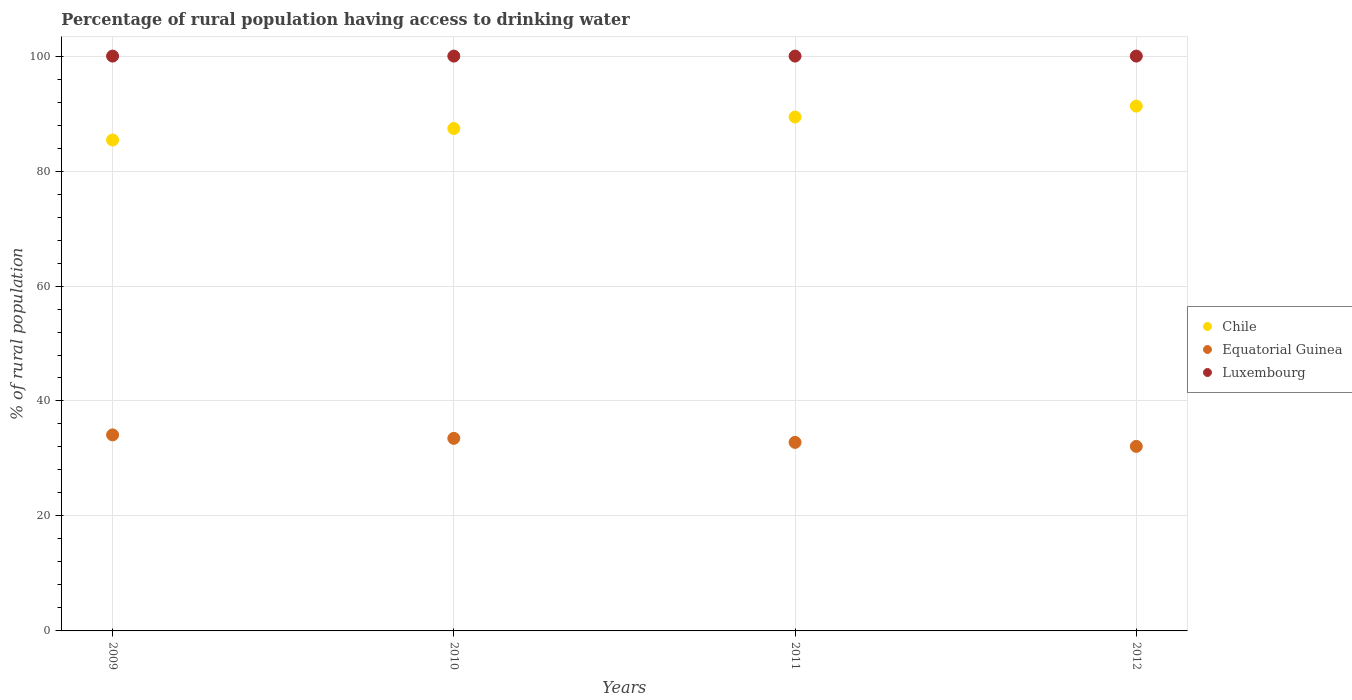Is the number of dotlines equal to the number of legend labels?
Your answer should be compact. Yes. What is the percentage of rural population having access to drinking water in Luxembourg in 2012?
Your response must be concise. 100. Across all years, what is the maximum percentage of rural population having access to drinking water in Luxembourg?
Ensure brevity in your answer.  100. Across all years, what is the minimum percentage of rural population having access to drinking water in Equatorial Guinea?
Provide a short and direct response. 32.1. In which year was the percentage of rural population having access to drinking water in Luxembourg maximum?
Your response must be concise. 2009. What is the total percentage of rural population having access to drinking water in Equatorial Guinea in the graph?
Give a very brief answer. 132.5. What is the difference between the percentage of rural population having access to drinking water in Chile in 2011 and that in 2012?
Ensure brevity in your answer.  -1.9. What is the difference between the percentage of rural population having access to drinking water in Luxembourg in 2009 and the percentage of rural population having access to drinking water in Chile in 2010?
Offer a very short reply. 12.6. What is the average percentage of rural population having access to drinking water in Chile per year?
Provide a short and direct response. 88.38. In the year 2009, what is the difference between the percentage of rural population having access to drinking water in Equatorial Guinea and percentage of rural population having access to drinking water in Chile?
Ensure brevity in your answer.  -51.3. What is the ratio of the percentage of rural population having access to drinking water in Chile in 2009 to that in 2010?
Offer a terse response. 0.98. Is the percentage of rural population having access to drinking water in Equatorial Guinea in 2011 less than that in 2012?
Offer a very short reply. No. What is the difference between the highest and the lowest percentage of rural population having access to drinking water in Chile?
Offer a terse response. 5.9. In how many years, is the percentage of rural population having access to drinking water in Equatorial Guinea greater than the average percentage of rural population having access to drinking water in Equatorial Guinea taken over all years?
Provide a short and direct response. 2. Is the sum of the percentage of rural population having access to drinking water in Luxembourg in 2010 and 2011 greater than the maximum percentage of rural population having access to drinking water in Equatorial Guinea across all years?
Your answer should be very brief. Yes. Is it the case that in every year, the sum of the percentage of rural population having access to drinking water in Luxembourg and percentage of rural population having access to drinking water in Equatorial Guinea  is greater than the percentage of rural population having access to drinking water in Chile?
Make the answer very short. Yes. Does the percentage of rural population having access to drinking water in Luxembourg monotonically increase over the years?
Make the answer very short. No. Is the percentage of rural population having access to drinking water in Luxembourg strictly greater than the percentage of rural population having access to drinking water in Equatorial Guinea over the years?
Your answer should be compact. Yes. Is the percentage of rural population having access to drinking water in Luxembourg strictly less than the percentage of rural population having access to drinking water in Equatorial Guinea over the years?
Offer a very short reply. No. How many dotlines are there?
Offer a very short reply. 3. How many years are there in the graph?
Provide a short and direct response. 4. What is the difference between two consecutive major ticks on the Y-axis?
Your answer should be very brief. 20. Does the graph contain grids?
Your answer should be compact. Yes. How many legend labels are there?
Ensure brevity in your answer.  3. How are the legend labels stacked?
Make the answer very short. Vertical. What is the title of the graph?
Your answer should be very brief. Percentage of rural population having access to drinking water. Does "Grenada" appear as one of the legend labels in the graph?
Provide a short and direct response. No. What is the label or title of the X-axis?
Your response must be concise. Years. What is the label or title of the Y-axis?
Ensure brevity in your answer.  % of rural population. What is the % of rural population of Chile in 2009?
Your answer should be very brief. 85.4. What is the % of rural population in Equatorial Guinea in 2009?
Make the answer very short. 34.1. What is the % of rural population of Luxembourg in 2009?
Your response must be concise. 100. What is the % of rural population of Chile in 2010?
Offer a very short reply. 87.4. What is the % of rural population in Equatorial Guinea in 2010?
Keep it short and to the point. 33.5. What is the % of rural population of Chile in 2011?
Ensure brevity in your answer.  89.4. What is the % of rural population in Equatorial Guinea in 2011?
Your answer should be compact. 32.8. What is the % of rural population of Chile in 2012?
Provide a short and direct response. 91.3. What is the % of rural population of Equatorial Guinea in 2012?
Provide a short and direct response. 32.1. What is the % of rural population in Luxembourg in 2012?
Your answer should be very brief. 100. Across all years, what is the maximum % of rural population in Chile?
Offer a very short reply. 91.3. Across all years, what is the maximum % of rural population in Equatorial Guinea?
Offer a terse response. 34.1. Across all years, what is the minimum % of rural population in Chile?
Offer a very short reply. 85.4. Across all years, what is the minimum % of rural population in Equatorial Guinea?
Give a very brief answer. 32.1. Across all years, what is the minimum % of rural population in Luxembourg?
Your response must be concise. 100. What is the total % of rural population in Chile in the graph?
Give a very brief answer. 353.5. What is the total % of rural population of Equatorial Guinea in the graph?
Your answer should be very brief. 132.5. What is the total % of rural population in Luxembourg in the graph?
Make the answer very short. 400. What is the difference between the % of rural population of Equatorial Guinea in 2009 and that in 2010?
Offer a very short reply. 0.6. What is the difference between the % of rural population in Chile in 2009 and that in 2012?
Make the answer very short. -5.9. What is the difference between the % of rural population of Luxembourg in 2009 and that in 2012?
Provide a short and direct response. 0. What is the difference between the % of rural population of Equatorial Guinea in 2010 and that in 2011?
Give a very brief answer. 0.7. What is the difference between the % of rural population of Luxembourg in 2010 and that in 2012?
Make the answer very short. 0. What is the difference between the % of rural population in Chile in 2011 and that in 2012?
Provide a succinct answer. -1.9. What is the difference between the % of rural population of Equatorial Guinea in 2011 and that in 2012?
Your response must be concise. 0.7. What is the difference between the % of rural population of Luxembourg in 2011 and that in 2012?
Make the answer very short. 0. What is the difference between the % of rural population of Chile in 2009 and the % of rural population of Equatorial Guinea in 2010?
Keep it short and to the point. 51.9. What is the difference between the % of rural population in Chile in 2009 and the % of rural population in Luxembourg in 2010?
Provide a short and direct response. -14.6. What is the difference between the % of rural population in Equatorial Guinea in 2009 and the % of rural population in Luxembourg in 2010?
Ensure brevity in your answer.  -65.9. What is the difference between the % of rural population of Chile in 2009 and the % of rural population of Equatorial Guinea in 2011?
Offer a very short reply. 52.6. What is the difference between the % of rural population in Chile in 2009 and the % of rural population in Luxembourg in 2011?
Give a very brief answer. -14.6. What is the difference between the % of rural population in Equatorial Guinea in 2009 and the % of rural population in Luxembourg in 2011?
Your answer should be very brief. -65.9. What is the difference between the % of rural population in Chile in 2009 and the % of rural population in Equatorial Guinea in 2012?
Your response must be concise. 53.3. What is the difference between the % of rural population in Chile in 2009 and the % of rural population in Luxembourg in 2012?
Provide a succinct answer. -14.6. What is the difference between the % of rural population of Equatorial Guinea in 2009 and the % of rural population of Luxembourg in 2012?
Make the answer very short. -65.9. What is the difference between the % of rural population in Chile in 2010 and the % of rural population in Equatorial Guinea in 2011?
Provide a short and direct response. 54.6. What is the difference between the % of rural population of Chile in 2010 and the % of rural population of Luxembourg in 2011?
Keep it short and to the point. -12.6. What is the difference between the % of rural population of Equatorial Guinea in 2010 and the % of rural population of Luxembourg in 2011?
Keep it short and to the point. -66.5. What is the difference between the % of rural population in Chile in 2010 and the % of rural population in Equatorial Guinea in 2012?
Your response must be concise. 55.3. What is the difference between the % of rural population in Equatorial Guinea in 2010 and the % of rural population in Luxembourg in 2012?
Offer a very short reply. -66.5. What is the difference between the % of rural population in Chile in 2011 and the % of rural population in Equatorial Guinea in 2012?
Offer a very short reply. 57.3. What is the difference between the % of rural population of Equatorial Guinea in 2011 and the % of rural population of Luxembourg in 2012?
Offer a terse response. -67.2. What is the average % of rural population in Chile per year?
Provide a succinct answer. 88.38. What is the average % of rural population in Equatorial Guinea per year?
Make the answer very short. 33.12. In the year 2009, what is the difference between the % of rural population of Chile and % of rural population of Equatorial Guinea?
Make the answer very short. 51.3. In the year 2009, what is the difference between the % of rural population in Chile and % of rural population in Luxembourg?
Provide a short and direct response. -14.6. In the year 2009, what is the difference between the % of rural population in Equatorial Guinea and % of rural population in Luxembourg?
Ensure brevity in your answer.  -65.9. In the year 2010, what is the difference between the % of rural population in Chile and % of rural population in Equatorial Guinea?
Your answer should be compact. 53.9. In the year 2010, what is the difference between the % of rural population of Chile and % of rural population of Luxembourg?
Keep it short and to the point. -12.6. In the year 2010, what is the difference between the % of rural population of Equatorial Guinea and % of rural population of Luxembourg?
Your answer should be very brief. -66.5. In the year 2011, what is the difference between the % of rural population in Chile and % of rural population in Equatorial Guinea?
Provide a short and direct response. 56.6. In the year 2011, what is the difference between the % of rural population in Equatorial Guinea and % of rural population in Luxembourg?
Your answer should be compact. -67.2. In the year 2012, what is the difference between the % of rural population of Chile and % of rural population of Equatorial Guinea?
Make the answer very short. 59.2. In the year 2012, what is the difference between the % of rural population of Chile and % of rural population of Luxembourg?
Provide a succinct answer. -8.7. In the year 2012, what is the difference between the % of rural population in Equatorial Guinea and % of rural population in Luxembourg?
Give a very brief answer. -67.9. What is the ratio of the % of rural population of Chile in 2009 to that in 2010?
Offer a terse response. 0.98. What is the ratio of the % of rural population of Equatorial Guinea in 2009 to that in 2010?
Your response must be concise. 1.02. What is the ratio of the % of rural population in Luxembourg in 2009 to that in 2010?
Make the answer very short. 1. What is the ratio of the % of rural population in Chile in 2009 to that in 2011?
Provide a succinct answer. 0.96. What is the ratio of the % of rural population of Equatorial Guinea in 2009 to that in 2011?
Keep it short and to the point. 1.04. What is the ratio of the % of rural population of Chile in 2009 to that in 2012?
Offer a very short reply. 0.94. What is the ratio of the % of rural population of Equatorial Guinea in 2009 to that in 2012?
Make the answer very short. 1.06. What is the ratio of the % of rural population of Chile in 2010 to that in 2011?
Offer a terse response. 0.98. What is the ratio of the % of rural population of Equatorial Guinea in 2010 to that in 2011?
Provide a short and direct response. 1.02. What is the ratio of the % of rural population in Chile in 2010 to that in 2012?
Provide a short and direct response. 0.96. What is the ratio of the % of rural population in Equatorial Guinea in 2010 to that in 2012?
Your answer should be compact. 1.04. What is the ratio of the % of rural population in Luxembourg in 2010 to that in 2012?
Offer a very short reply. 1. What is the ratio of the % of rural population of Chile in 2011 to that in 2012?
Keep it short and to the point. 0.98. What is the ratio of the % of rural population of Equatorial Guinea in 2011 to that in 2012?
Provide a succinct answer. 1.02. What is the ratio of the % of rural population of Luxembourg in 2011 to that in 2012?
Make the answer very short. 1. What is the difference between the highest and the lowest % of rural population in Luxembourg?
Offer a terse response. 0. 